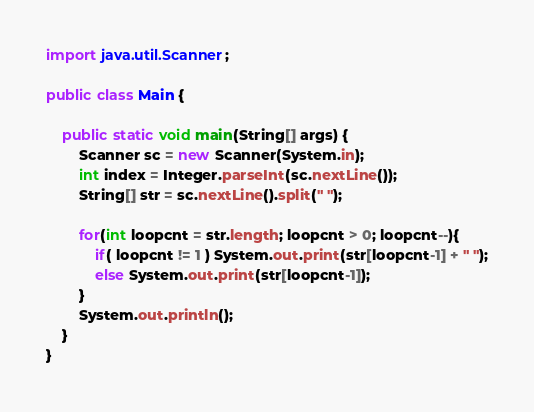<code> <loc_0><loc_0><loc_500><loc_500><_Java_>import java.util.Scanner;
 
public class Main {
 
    public static void main(String[] args) {
        Scanner sc = new Scanner(System.in);
        int index = Integer.parseInt(sc.nextLine());
        String[] str = sc.nextLine().split(" ");
 
        for(int loopcnt = str.length; loopcnt > 0; loopcnt--){
            if( loopcnt != 1 ) System.out.print(str[loopcnt-1] + " ");
            else System.out.print(str[loopcnt-1]);
        }
        System.out.println();
    }
}</code> 